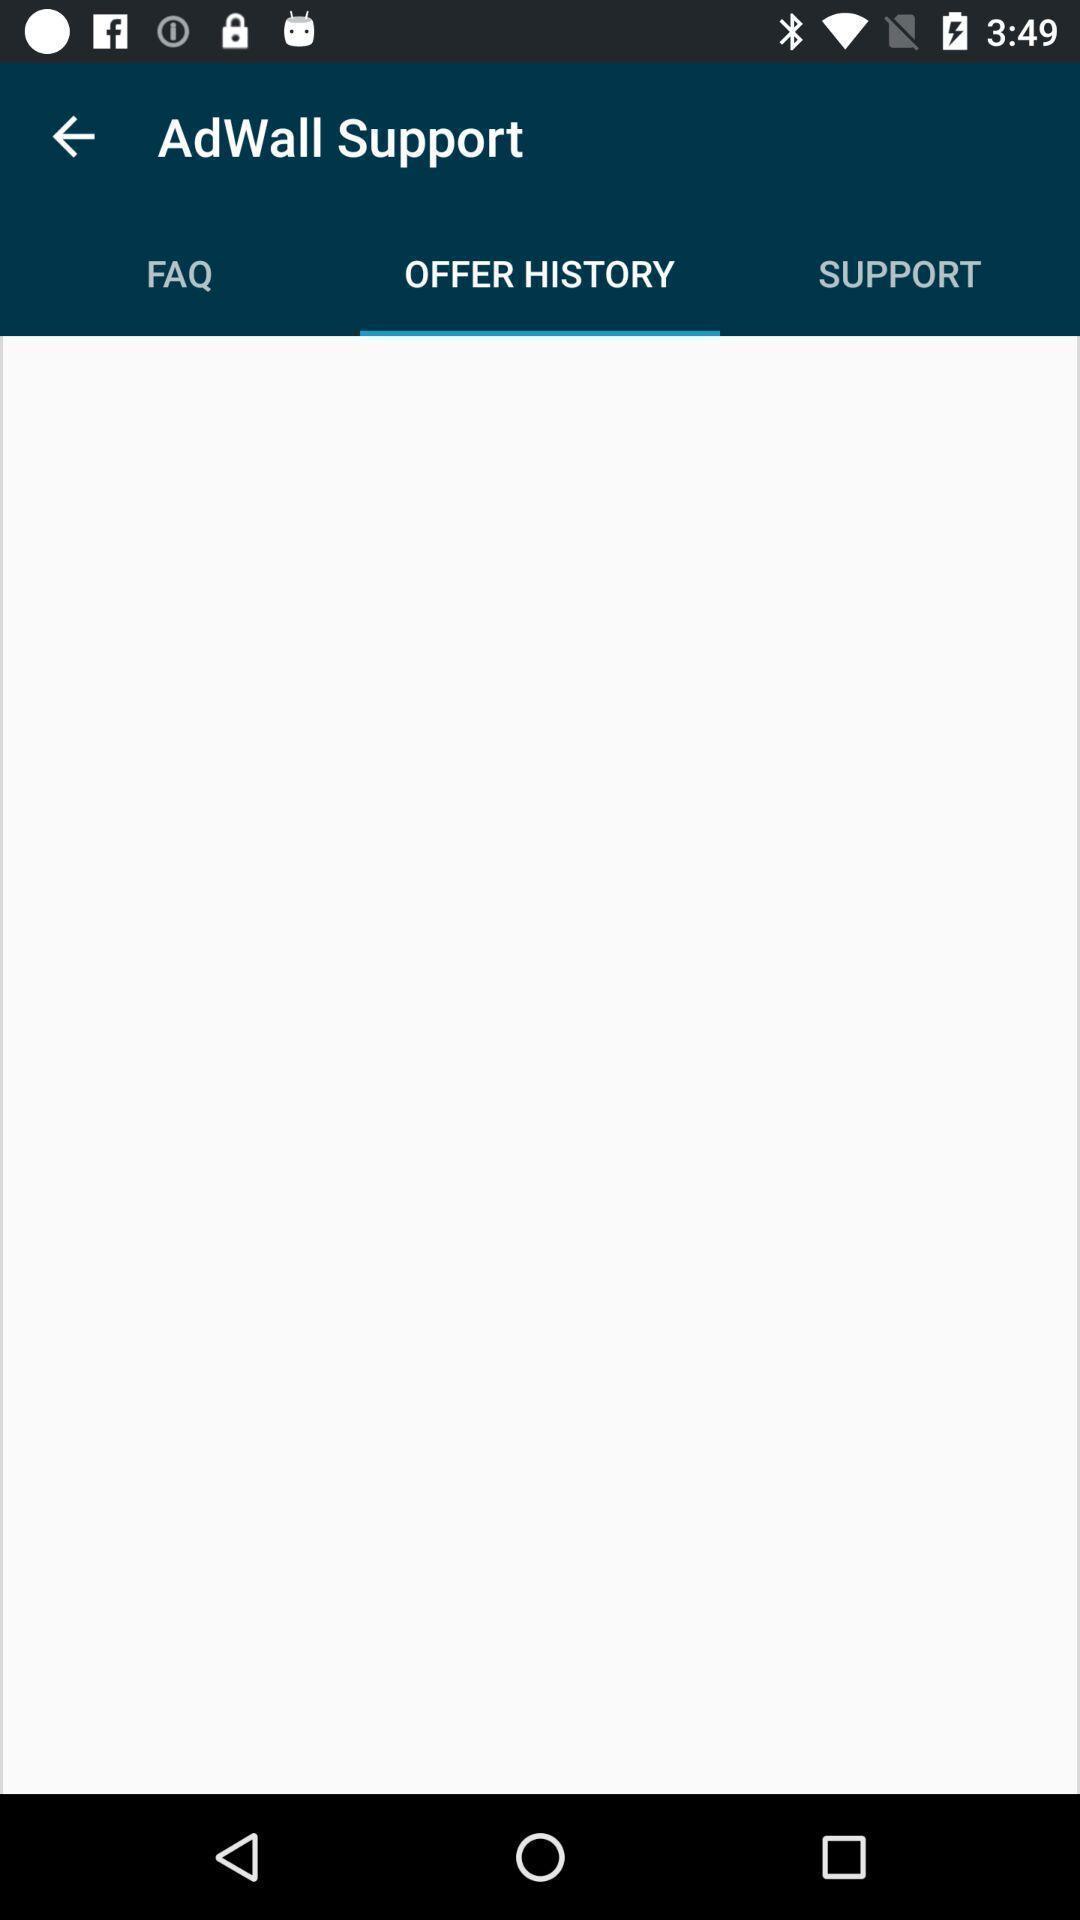Tell me about the visual elements in this screen capture. Screen displaying multiple options. 